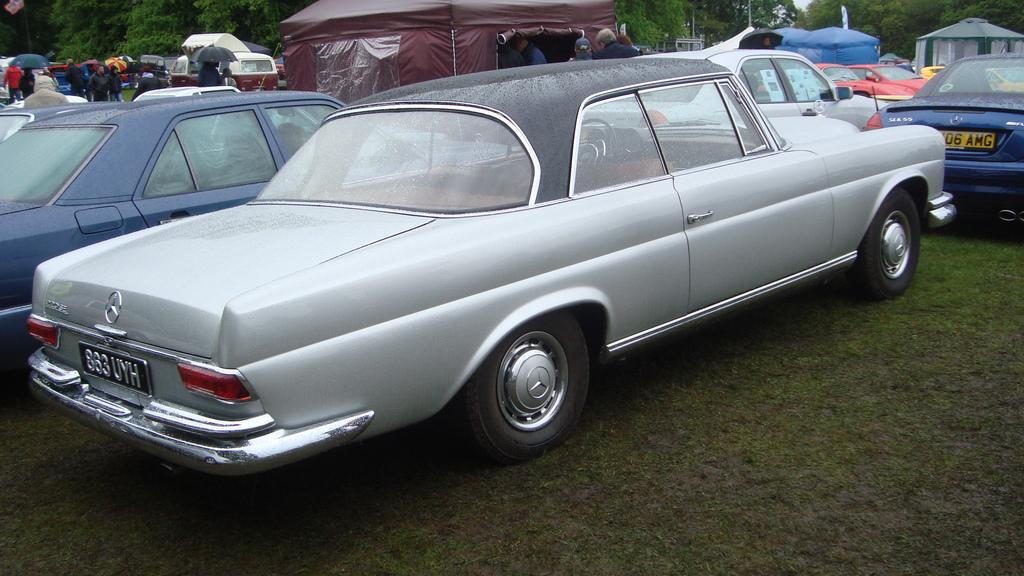What types of objects can be seen in the image? There are vehicles, tents, and umbrellas in the image. What natural elements are present in the image? Trees and grass are visible in the image. Are there any people in the image? Yes, there are people in the image. What type of chalk is being used by the people in the image? There is no chalk present in the image. How many screws can be seen holding the tents together in the image? There is no mention of screws in the image; the tents are likely secured by other means. 